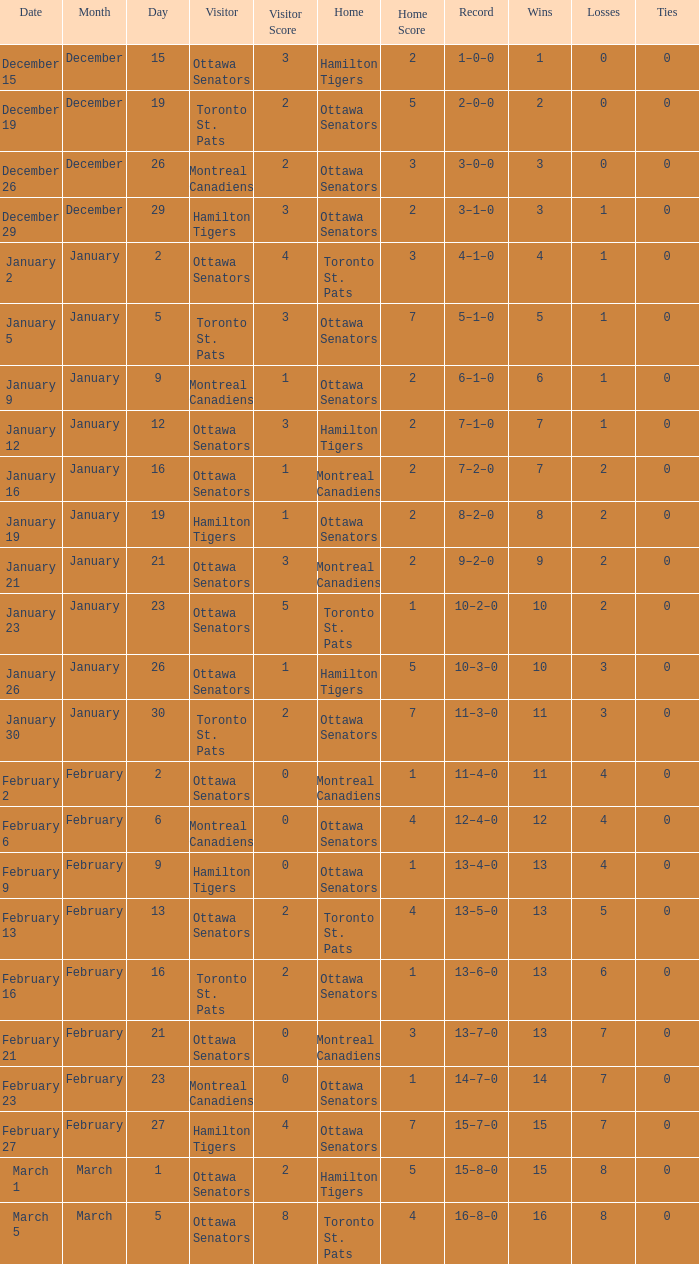Which home team had a visitor of Ottawa Senators with a score of 1–5? Hamilton Tigers. 